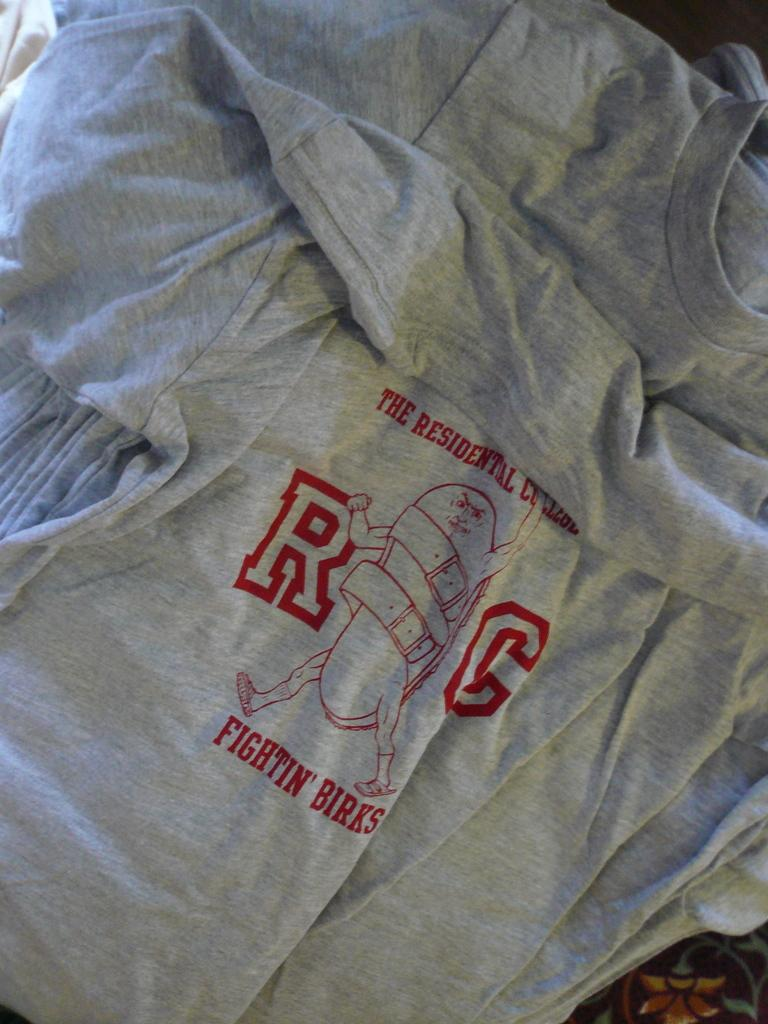<image>
Give a short and clear explanation of the subsequent image. the word Birks is on the gray shirt 